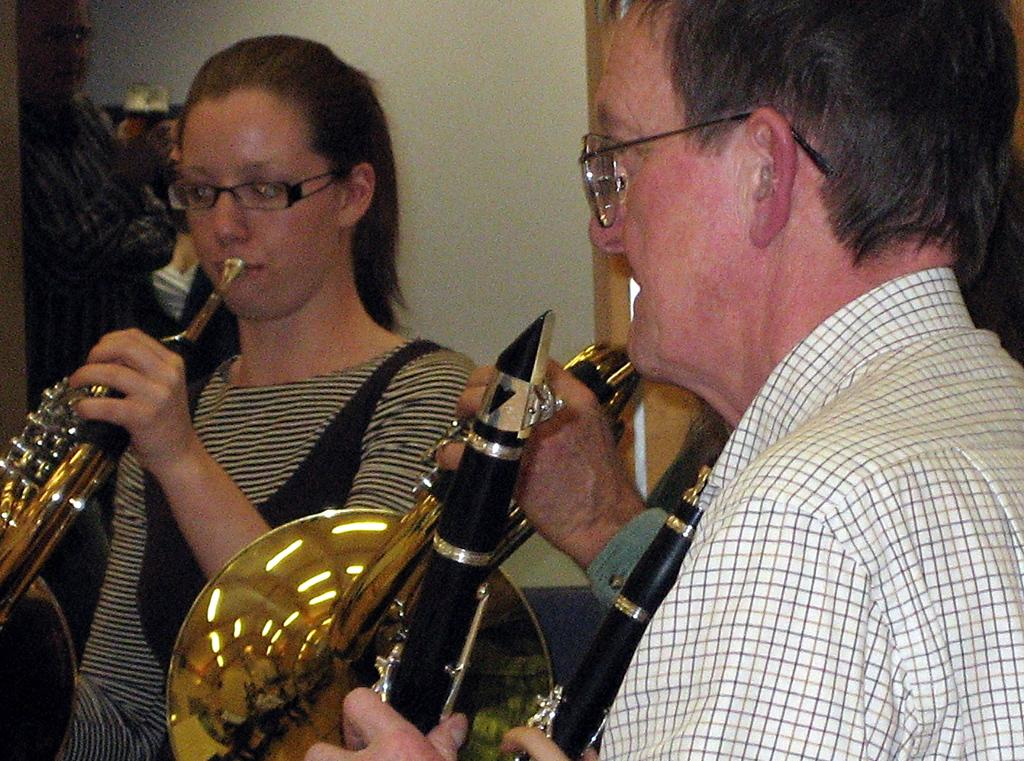What is happening in the image involving a group of people? There is a group of people in the image, and they are playing musical instruments. Where are the people located in the image? The people are standing in a place. How are the musical instruments being used by the people in the image? The musical instruments are held in their hands. What type of feast is being prepared by the people in the image? There is no mention of a feast or any food preparation in the image; the people are playing musical instruments. How many cents are visible in the image? There is no reference to currency or money in the image; it features a group of people playing musical instruments. 